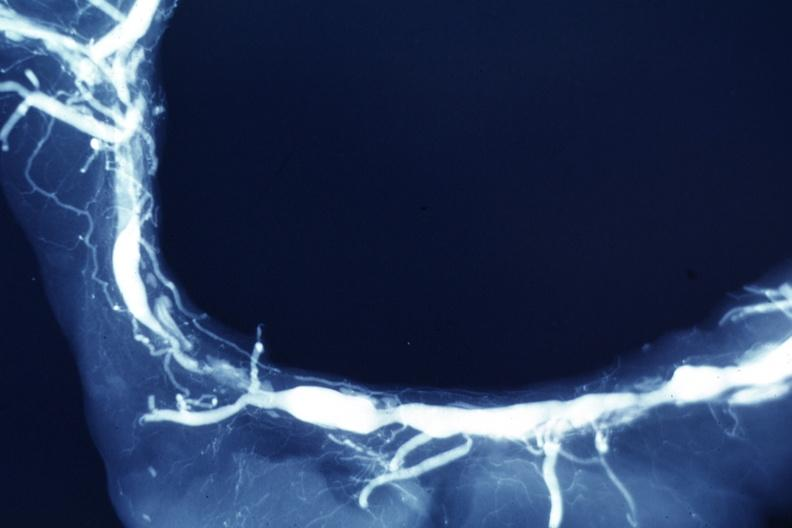does this image show x-ray postmortclose-up view of artery with extensive lesions very good example?
Answer the question using a single word or phrase. Yes 